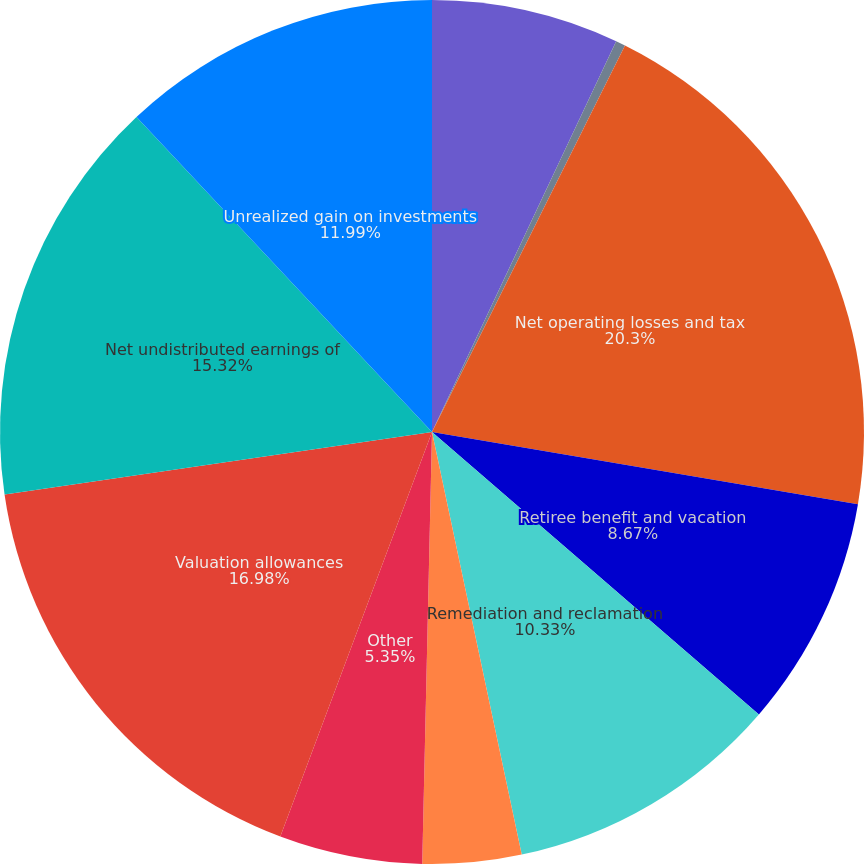Convert chart to OTSL. <chart><loc_0><loc_0><loc_500><loc_500><pie_chart><fcel>Exploration costs<fcel>Depreciation<fcel>Net operating losses and tax<fcel>Retiree benefit and vacation<fcel>Remediation and reclamation<fcel>Investment in partnerships<fcel>Other<fcel>Valuation allowances<fcel>Net undistributed earnings of<fcel>Unrealized gain on investments<nl><fcel>7.01%<fcel>0.36%<fcel>20.3%<fcel>8.67%<fcel>10.33%<fcel>3.69%<fcel>5.35%<fcel>16.98%<fcel>15.32%<fcel>11.99%<nl></chart> 